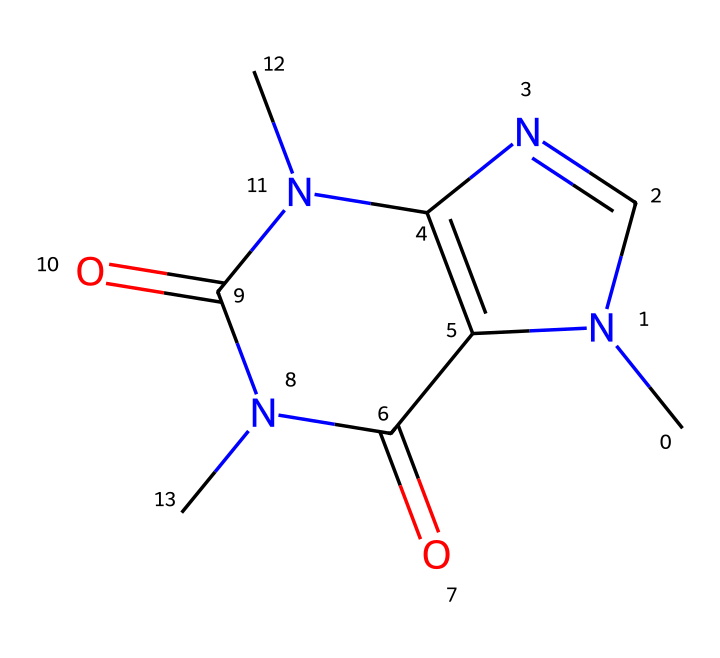What is the molecular formula of caffeine? By analyzing the SMILES representation, we can count the number of each type of atom present in the structure. In this case, caffeine consists of 8 carbon (C) atoms, 10 hydrogen (H) atoms, 4 nitrogen (N) atoms, and 2 oxygen (O) atoms, which together give the molecular formula C8H10N4O2.
Answer: C8H10N4O2 How many nitrogen atoms are in caffeine? From the SMILES representation, we can identify the number of nitrogen atoms by looking for the 'N' characters. In this case, there are 4 nitrogen atoms present in the structure.
Answer: 4 What type of functional groups are present in caffeine? The structure includes multiple functional groups, specifically the amine (due to nitrogen atoms bonded with hydrogen) and carbonyl (due to the presence of carbon-oxygen double bonds). The presence of these groups indicates that caffeine has both basic (amine) and acidic (carbonyl) properties.
Answer: amine and carbonyl What is the significance of the ring structure in caffeine? The ring structure in caffeine contributes to its stability and structure as an alkaloid. This cyclic nature is key to its biological activity, as it allows for specific interactions with receptors in the body, contributing to its stimulant effects.
Answer: stability and receptor interaction How many rings are present in the caffeine structure? By examining the SMILES representation, we can identify the cyclic parts of the structure. Caffeine contains 2 fused ring structures in its molecular architecture.
Answer: 2 What is the primary role of caffeine in sodas? The primary role of caffeine in sodas is to act as a stimulant due to its psychoactive properties, making it a popular ingredient in a variety of soft drinks. This effect is greatly influenced by the molecular structure that allows it to cross the blood-brain barrier efficiently.
Answer: stimulant 